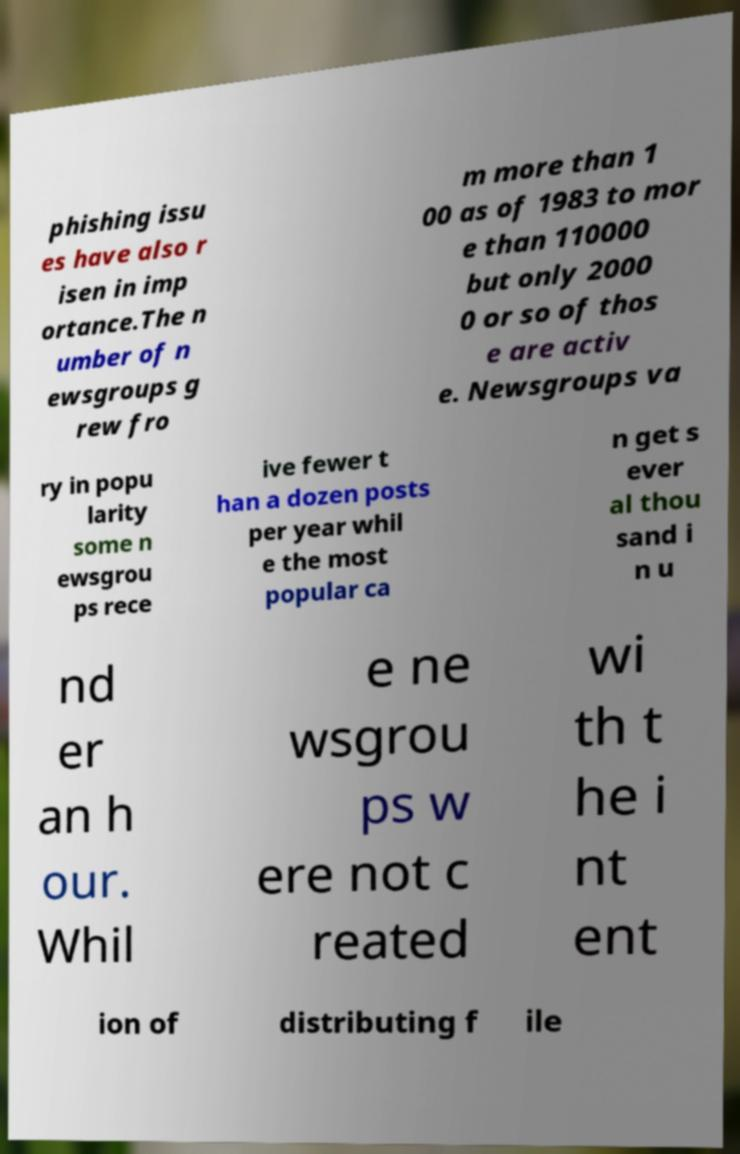What messages or text are displayed in this image? I need them in a readable, typed format. phishing issu es have also r isen in imp ortance.The n umber of n ewsgroups g rew fro m more than 1 00 as of 1983 to mor e than 110000 but only 2000 0 or so of thos e are activ e. Newsgroups va ry in popu larity some n ewsgrou ps rece ive fewer t han a dozen posts per year whil e the most popular ca n get s ever al thou sand i n u nd er an h our. Whil e ne wsgrou ps w ere not c reated wi th t he i nt ent ion of distributing f ile 